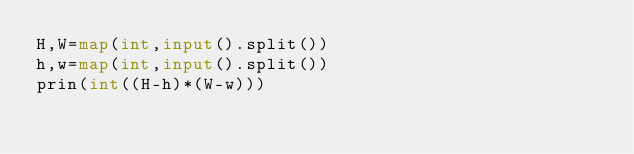Convert code to text. <code><loc_0><loc_0><loc_500><loc_500><_Python_>H,W=map(int,input().split())
h,w=map(int,input().split())
prin(int((H-h)*(W-w)))</code> 